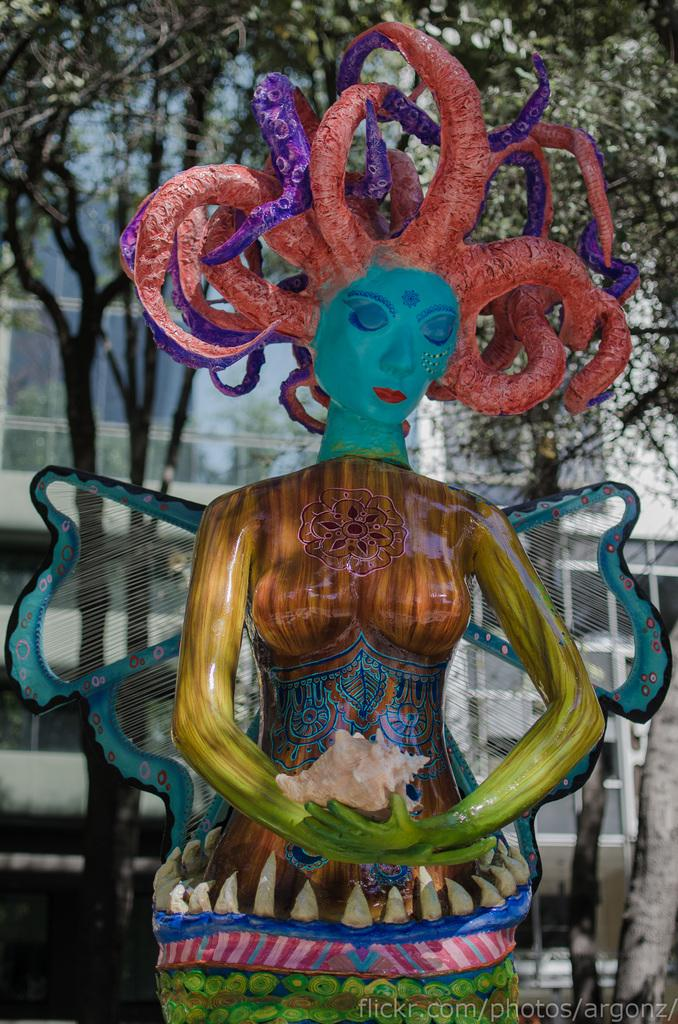What is the main subject of the image? There is a colorful statue in the image. Can you describe the statue? The statue is of a woman. What is the woman holding in the image? The woman is holding a shell. What can be seen in the background of the image? There are buildings and trees in the background of the image. How many cars are parked in front of the statue in the image? There are no cars visible in the image; it only features the statue and the background elements. What type of powder is being used to clean the statue in the image? There is no indication of any cleaning activity or powder in the image. 